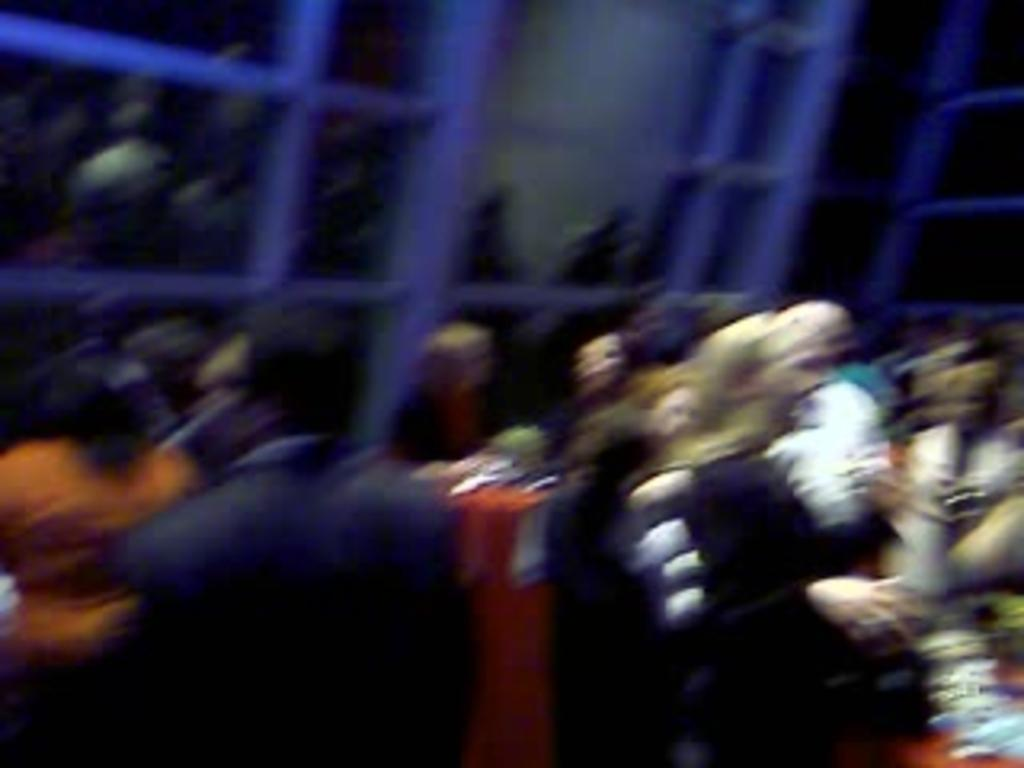What is the main subject of the image? The main subject of the image is a group of people. Can you describe the appearance of the group of people in the image? The group of people is blurry in the image. How many buns are being held by the people in the image? There is no mention of buns in the image, and therefore no such activity can be observed. 